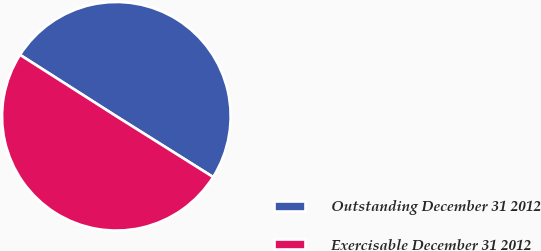<chart> <loc_0><loc_0><loc_500><loc_500><pie_chart><fcel>Outstanding December 31 2012<fcel>Exercisable December 31 2012<nl><fcel>49.89%<fcel>50.11%<nl></chart> 